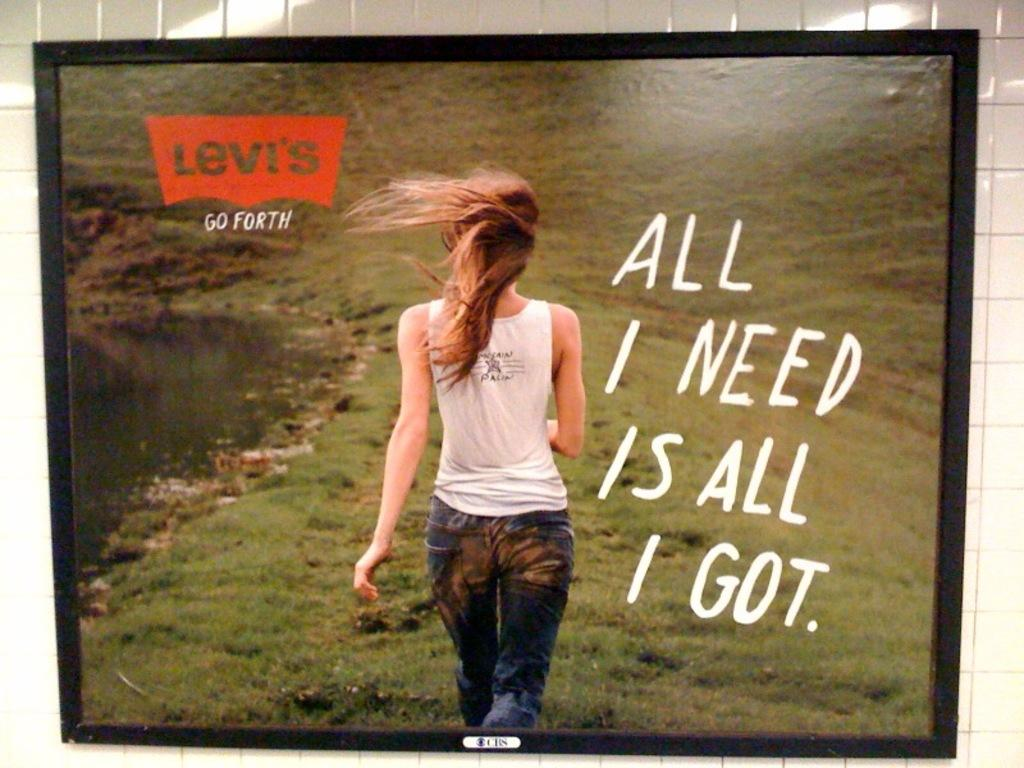What is hanging on the wall in the image? There is a frame on the wall in the image. What is depicted within the frame? The frame contains an image of a woman walking on the grass. What else can be seen in the image besides the frame? There is text and a logo visible in the image. How does the soap in the image contribute to the woman's trip on the grass? There is no soap present in the image; it only features a frame with an image of a woman walking on the grass, text, and a logo. 